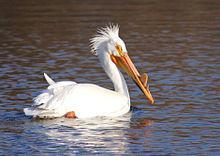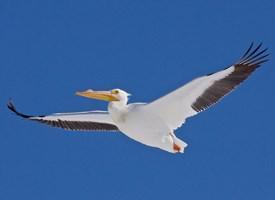The first image is the image on the left, the second image is the image on the right. Evaluate the accuracy of this statement regarding the images: "One long-beaked bird is floating on water, while a second is flying with wings stretched out showing the black feathery edges.". Is it true? Answer yes or no. Yes. 